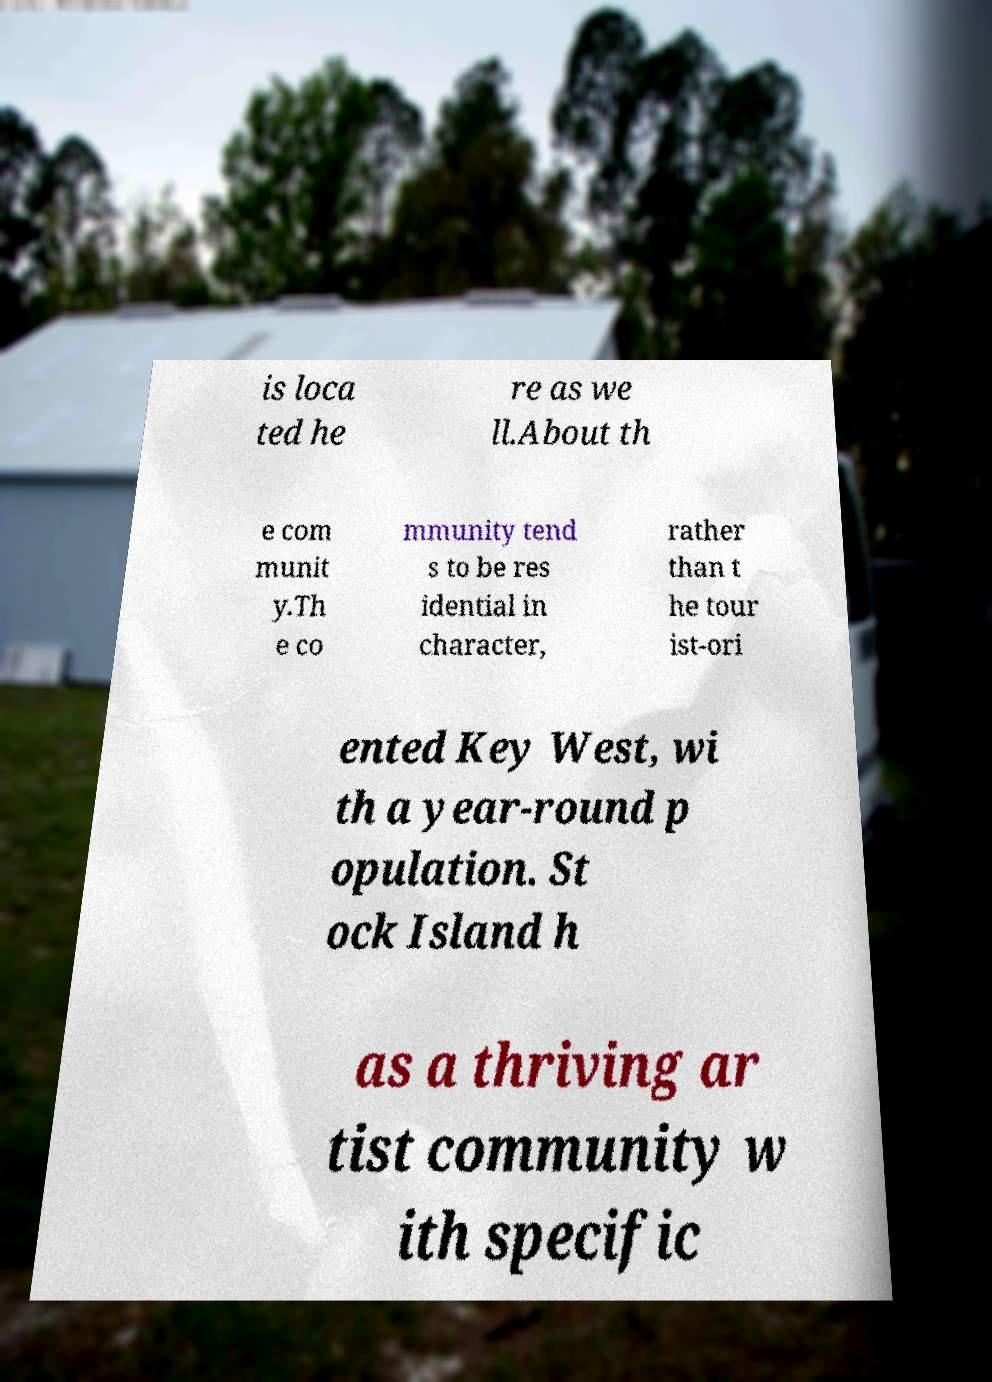Please identify and transcribe the text found in this image. is loca ted he re as we ll.About th e com munit y.Th e co mmunity tend s to be res idential in character, rather than t he tour ist-ori ented Key West, wi th a year-round p opulation. St ock Island h as a thriving ar tist community w ith specific 